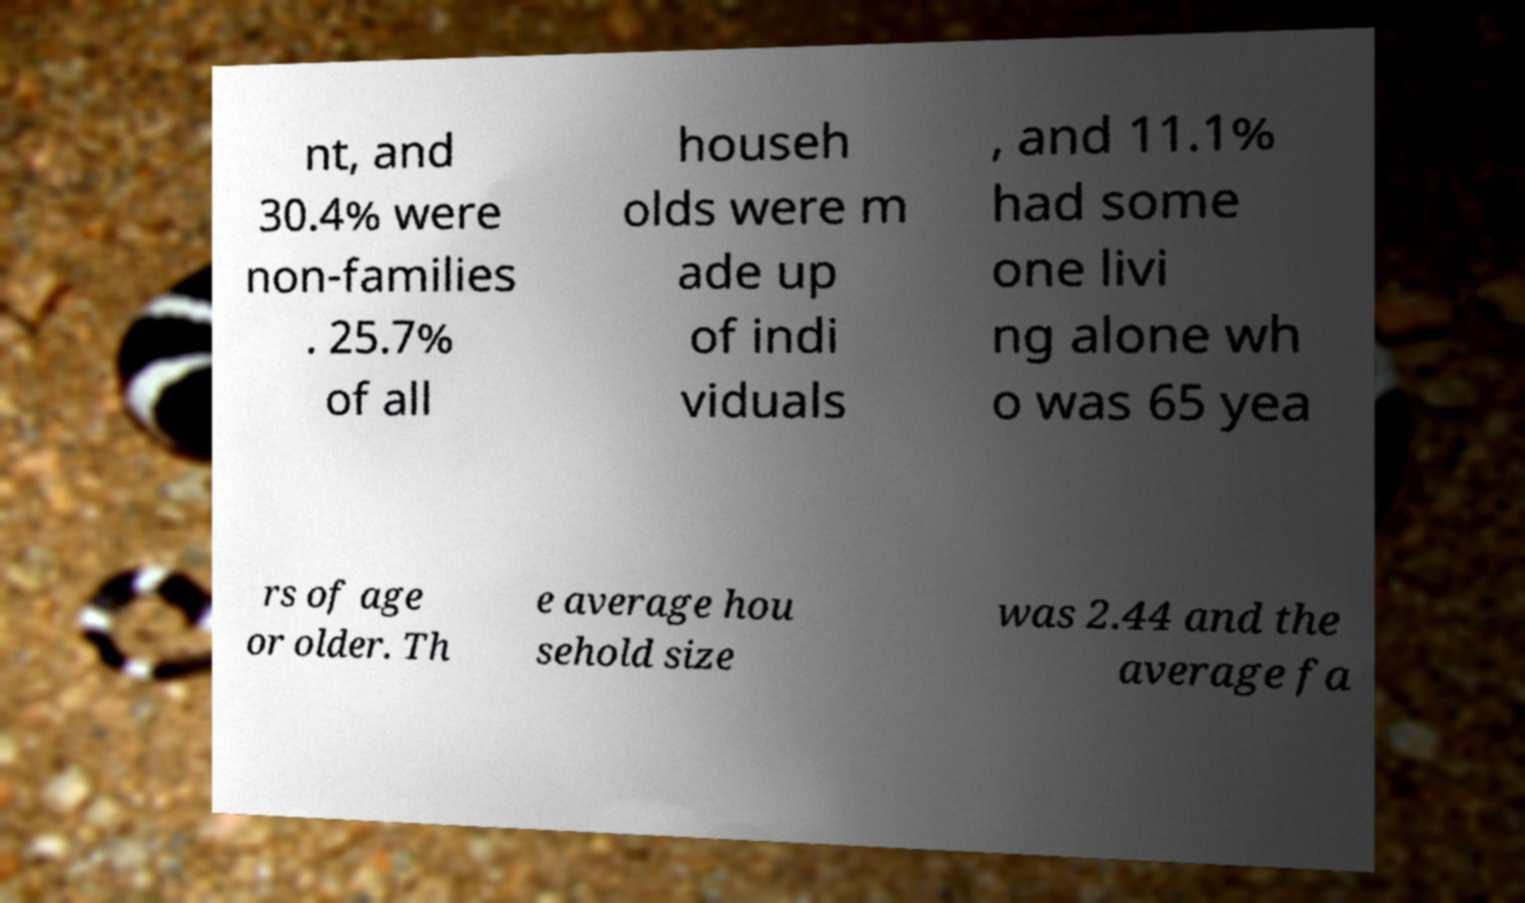Can you accurately transcribe the text from the provided image for me? nt, and 30.4% were non-families . 25.7% of all househ olds were m ade up of indi viduals , and 11.1% had some one livi ng alone wh o was 65 yea rs of age or older. Th e average hou sehold size was 2.44 and the average fa 